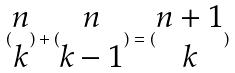Convert formula to latex. <formula><loc_0><loc_0><loc_500><loc_500>( \begin{matrix} n \\ k \end{matrix} ) + ( \begin{matrix} n \\ k - 1 \end{matrix} ) = ( \begin{matrix} n + 1 \\ k \end{matrix} )</formula> 